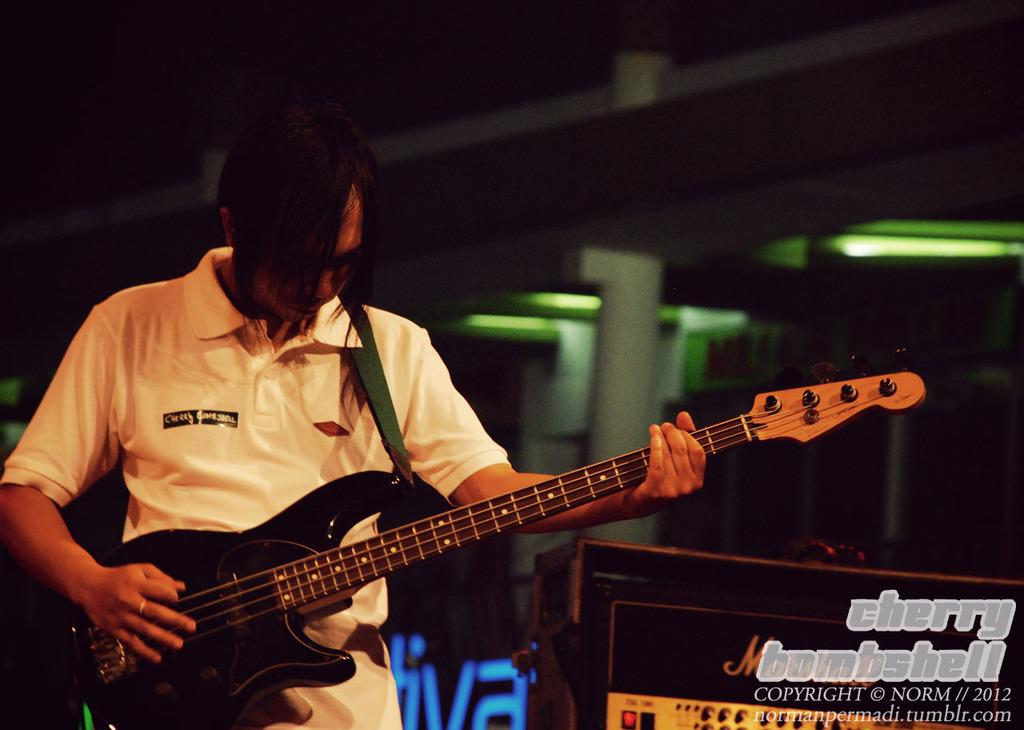What is the man in the image doing? The man is standing in the image and holding a guitar. What object is on the right side of the image? There is a speaker on the right side of the image. What can be seen in the background of the image? There is a wall and lights visible in the background of the image. What type of list is the man holding in the image? There is no list present in the image; the man is holding a guitar. Can you see a rabbit in the image? No, there is no rabbit present in the image. 